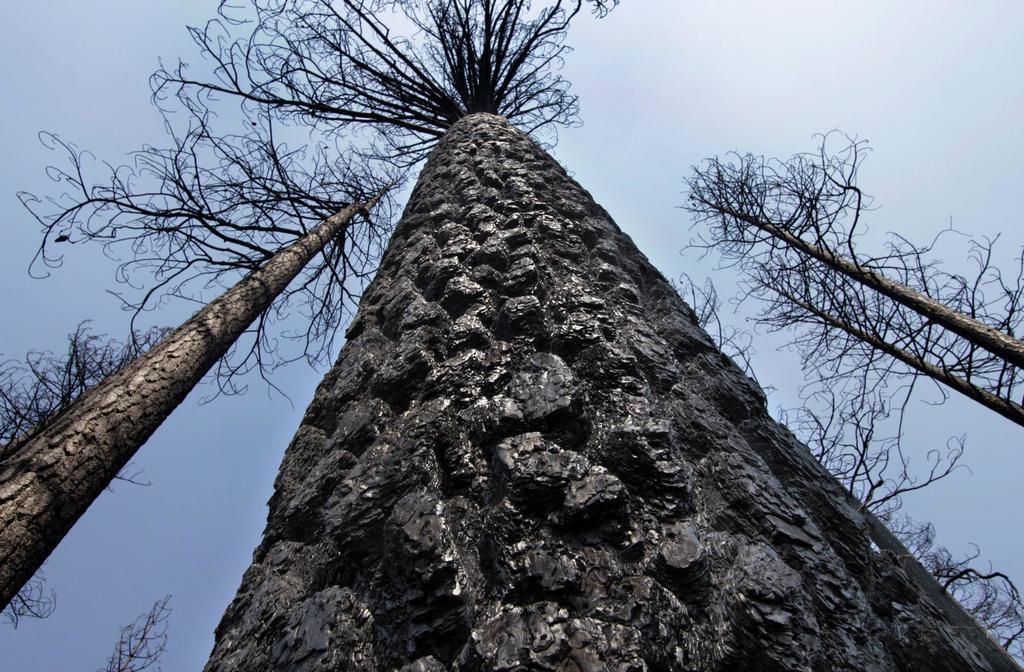Describe this image in one or two sentences. In this image we can see few trees. We can see the sky in the image. 